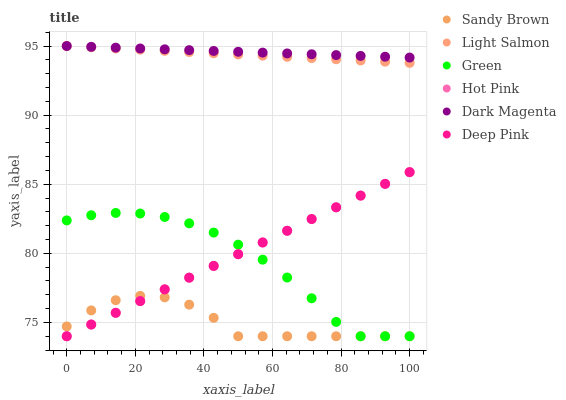Does Sandy Brown have the minimum area under the curve?
Answer yes or no. Yes. Does Dark Magenta have the maximum area under the curve?
Answer yes or no. Yes. Does Deep Pink have the minimum area under the curve?
Answer yes or no. No. Does Deep Pink have the maximum area under the curve?
Answer yes or no. No. Is Deep Pink the smoothest?
Answer yes or no. Yes. Is Sandy Brown the roughest?
Answer yes or no. Yes. Is Dark Magenta the smoothest?
Answer yes or no. No. Is Dark Magenta the roughest?
Answer yes or no. No. Does Deep Pink have the lowest value?
Answer yes or no. Yes. Does Dark Magenta have the lowest value?
Answer yes or no. No. Does Dark Magenta have the highest value?
Answer yes or no. Yes. Does Deep Pink have the highest value?
Answer yes or no. No. Is Sandy Brown less than Dark Magenta?
Answer yes or no. Yes. Is Dark Magenta greater than Sandy Brown?
Answer yes or no. Yes. Does Sandy Brown intersect Green?
Answer yes or no. Yes. Is Sandy Brown less than Green?
Answer yes or no. No. Is Sandy Brown greater than Green?
Answer yes or no. No. Does Sandy Brown intersect Dark Magenta?
Answer yes or no. No. 